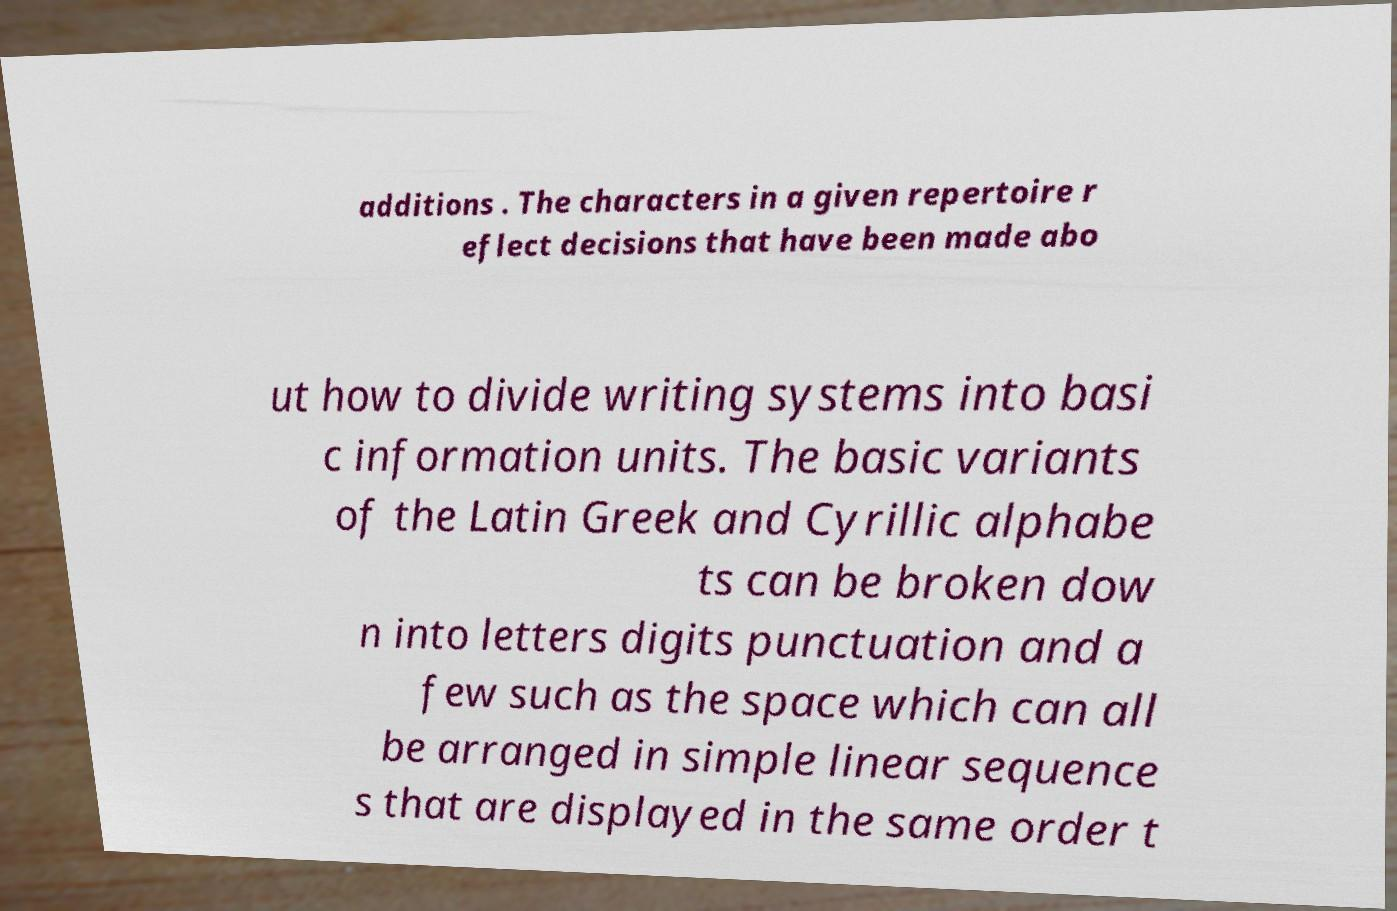I need the written content from this picture converted into text. Can you do that? additions . The characters in a given repertoire r eflect decisions that have been made abo ut how to divide writing systems into basi c information units. The basic variants of the Latin Greek and Cyrillic alphabe ts can be broken dow n into letters digits punctuation and a few such as the space which can all be arranged in simple linear sequence s that are displayed in the same order t 